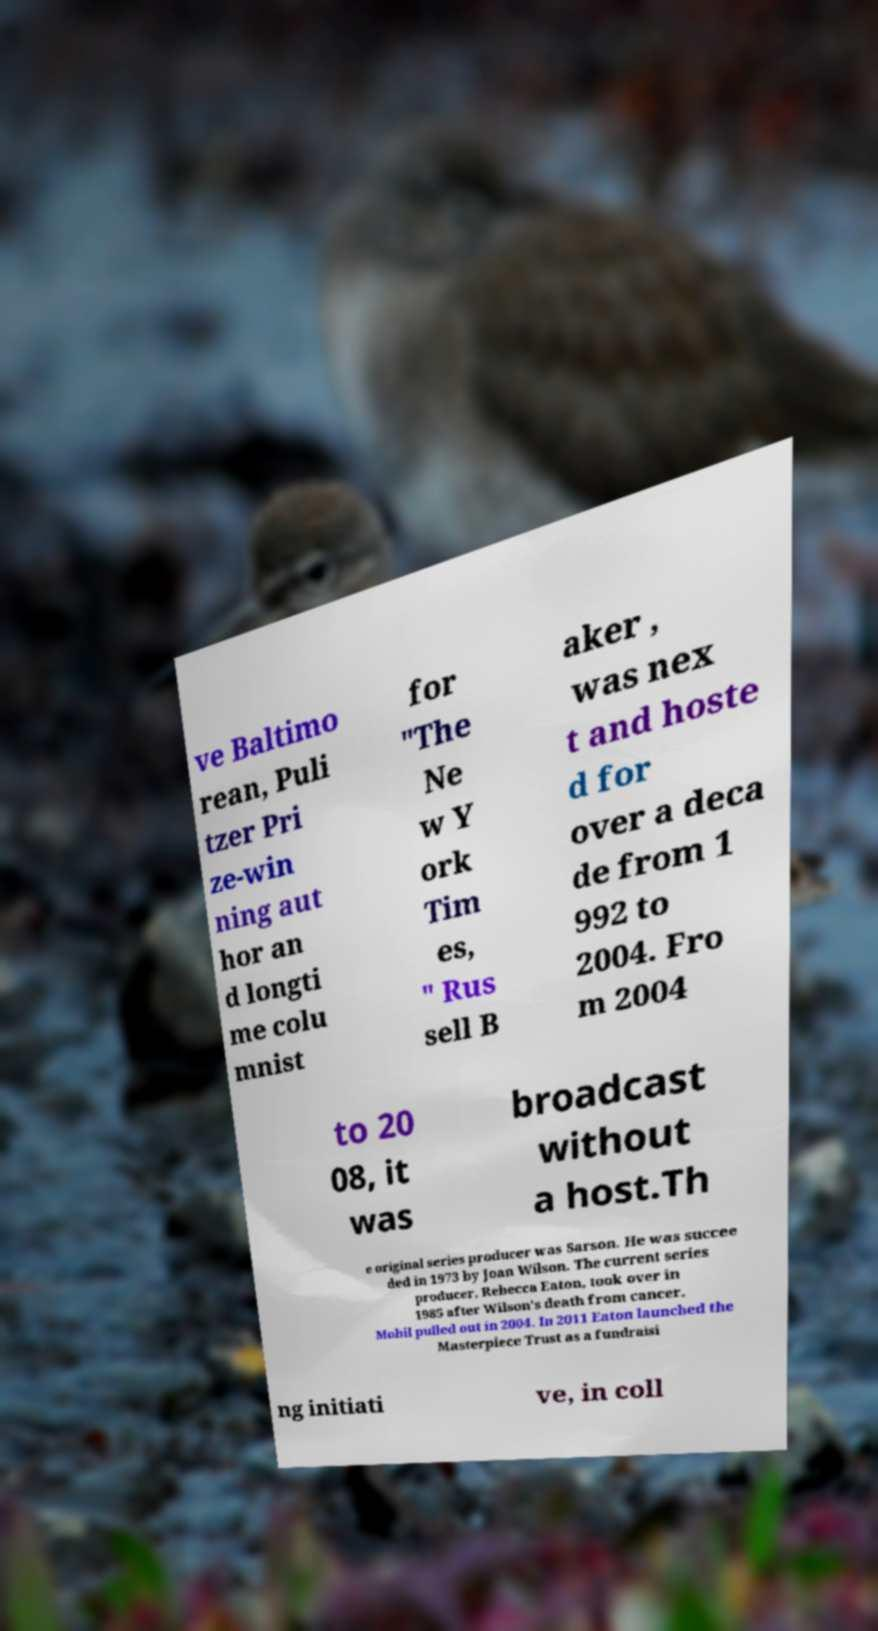I need the written content from this picture converted into text. Can you do that? ve Baltimo rean, Puli tzer Pri ze-win ning aut hor an d longti me colu mnist for "The Ne w Y ork Tim es, " Rus sell B aker , was nex t and hoste d for over a deca de from 1 992 to 2004. Fro m 2004 to 20 08, it was broadcast without a host.Th e original series producer was Sarson. He was succee ded in 1973 by Joan Wilson. The current series producer, Rebecca Eaton, took over in 1985 after Wilson's death from cancer. Mobil pulled out in 2004. In 2011 Eaton launched the Masterpiece Trust as a fundraisi ng initiati ve, in coll 